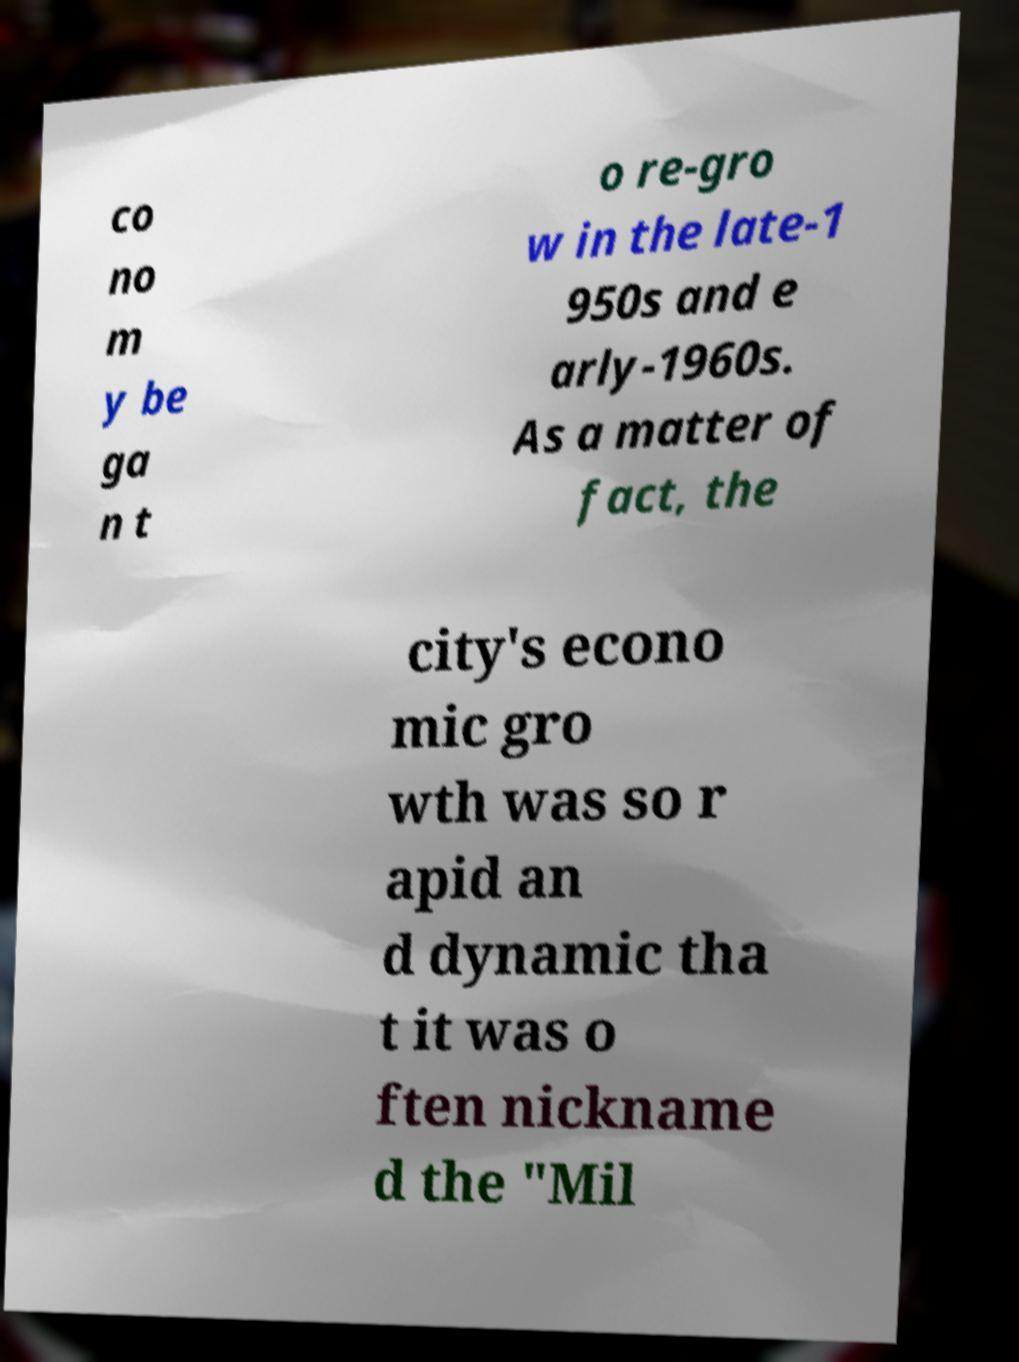I need the written content from this picture converted into text. Can you do that? co no m y be ga n t o re-gro w in the late-1 950s and e arly-1960s. As a matter of fact, the city's econo mic gro wth was so r apid an d dynamic tha t it was o ften nickname d the "Mil 